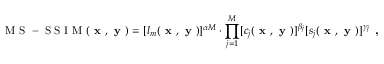<formula> <loc_0><loc_0><loc_500><loc_500>M S - S S I M ( x , y ) = [ l _ { m } ( x , y ) ] ^ { \alpha M } \cdot \prod _ { j = 1 } ^ { M } [ c _ { j } ( x , y ) ] ^ { \beta _ { j } } [ s _ { j } ( x , y ) ] ^ { \gamma _ { j } } ,</formula> 